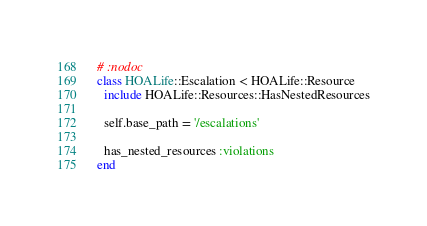Convert code to text. <code><loc_0><loc_0><loc_500><loc_500><_Ruby_># :nodoc
class HOALife::Escalation < HOALife::Resource
  include HOALife::Resources::HasNestedResources

  self.base_path = '/escalations'

  has_nested_resources :violations
end
</code> 